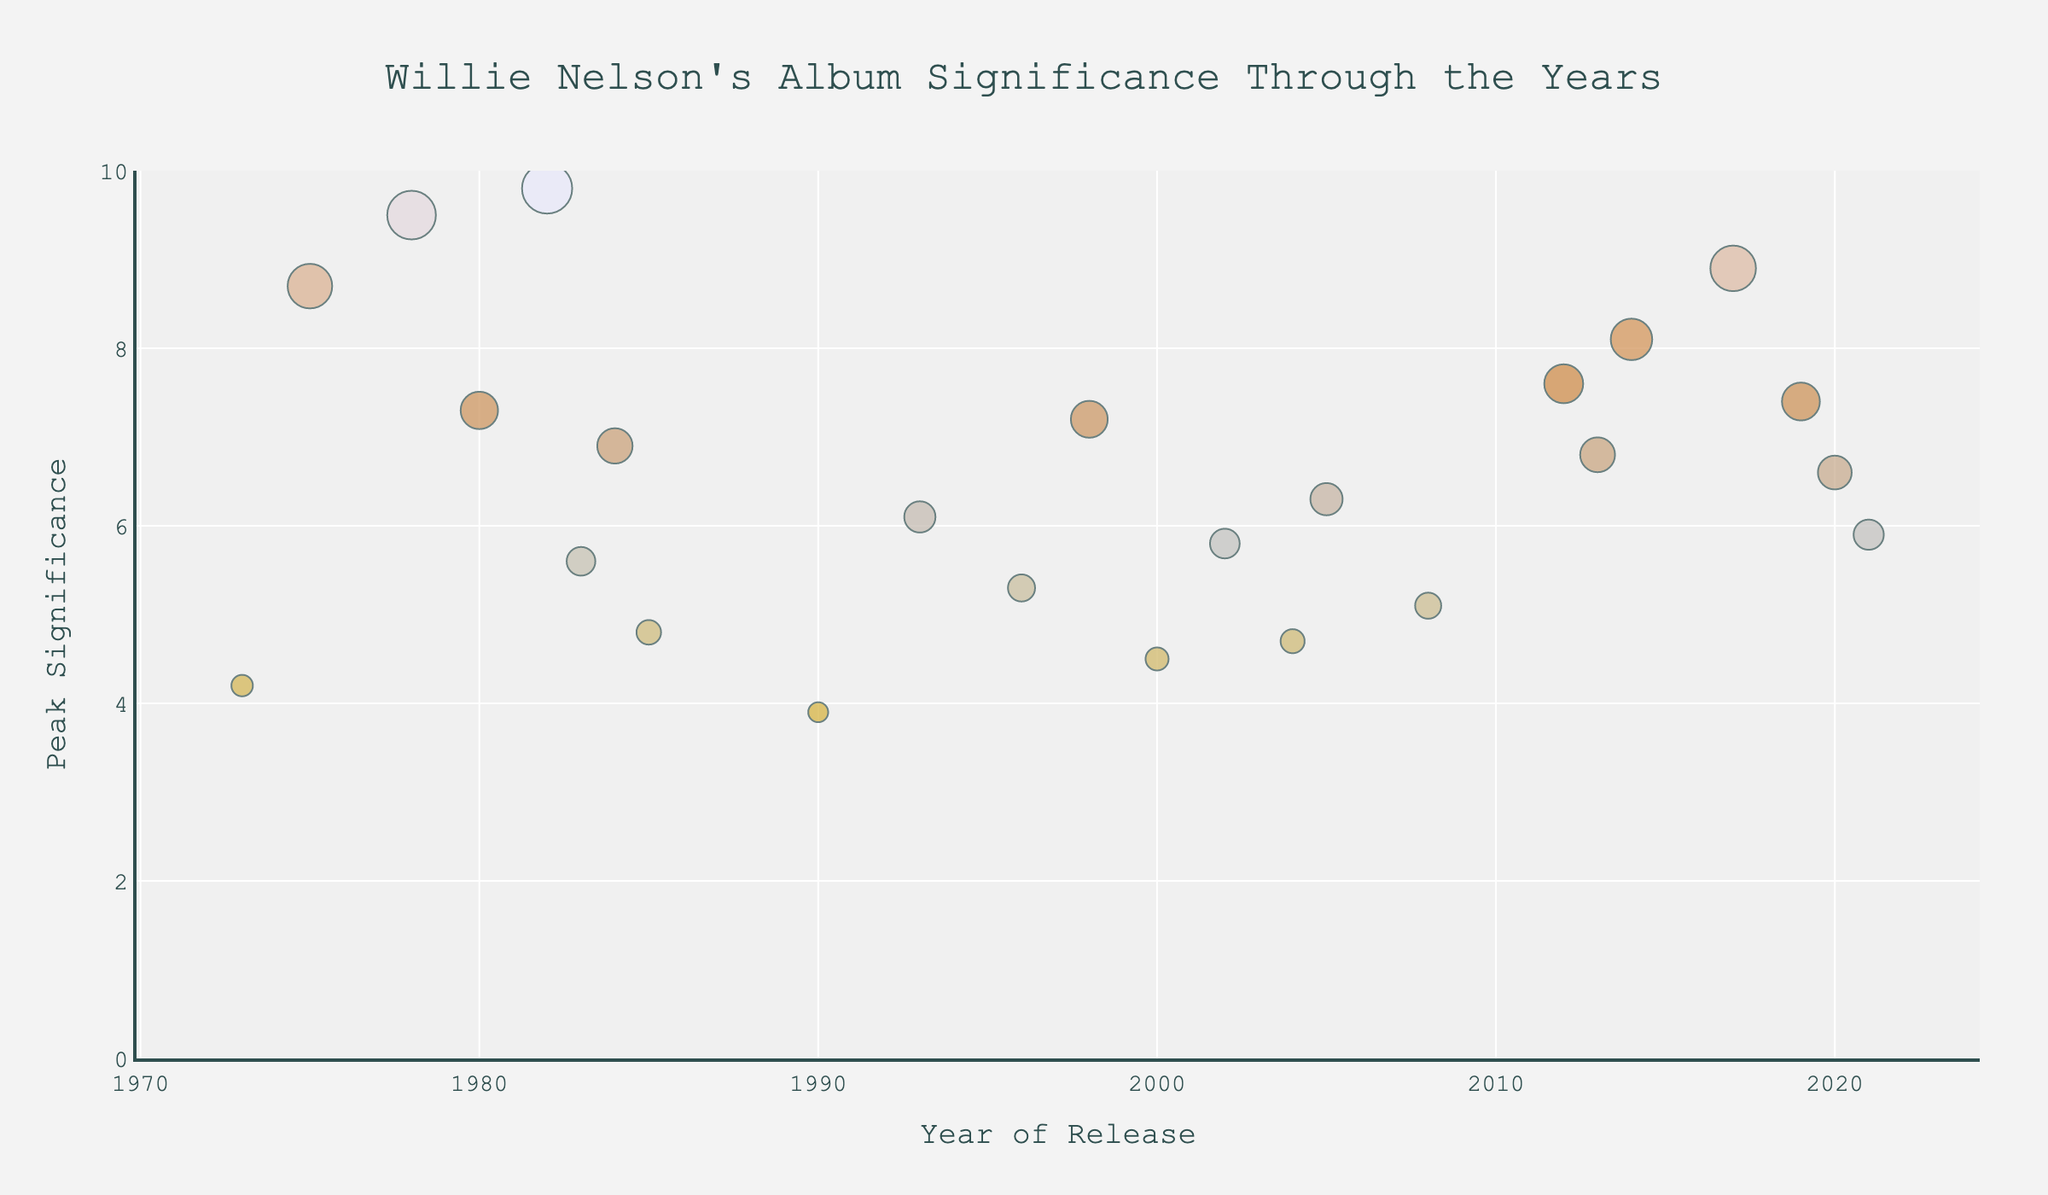How many albums were released by Willie Nelson in the 1970s? Check the data points plotted in the 1970s and count the distinct albums from 1973 to 1978. There are three albums: "Shotgun Willie" (1973), "Red Headed Stranger" (1975), and "Stardust" (1978).
Answer: 3 Which album has the highest peak significance and in what year was it released? Identify the data point with the maximum value on the Peak Significance axis. The highest value is 9.8, corresponding to "Always on My Mind" released in 1982.
Answer: "Always on My Mind," 1982 What is the median peak significance of Willie Nelson's albums released in the 2000s? List the peak significances from the 2000s: 4.5 (2000), 5.8 (2002), 4.7 (2004), 6.3 (2005), and 5.1 (2008). Arrange them and find the middle value: 4.5, 4.7, 5.1, 5.8, 6.3. The median is 5.1.
Answer: 5.1 Which decade shows the largest range in peak significance for Willie Nelson albums? Compare the ranges (max - min) of peak significances for each decade: 1970s (9.5 - 4.2 = 5.3), 1980s (7.3 - 4.8 = 2.5), 1990s (7.2 - 3.9 = 3.3), 2000s (6.3 - 4.5 = 1.8), 2010s (8.9 - 5.9 = 3). The 1970s has the largest range of 5.3.
Answer: 1970s How many albums have a peak significance greater than 7? Identify data points with Peak Significance above 7 and count them: "Red Headed Stranger" (8.7), "Stardust" (9.5), "Always on My Mind" (9.8), "Honeysuckle Rose" (7.3), "Heroes" (7.6), "Band of Brothers" (8.1), "God's Problem Child" (8.9), and "Ride Me Back Home" (7.4). There are eight such albums.
Answer: 8 Between 1980 and 1990, which album has the lowest peak significance, and what is that value? Examine the data points between 1980 and 1990 and identify the lowest value: "Born for Trouble" (1990) with a Peak Significance of 3.9.
Answer: "Born for Trouble," 3.9 What is the average peak significance for albums released in the 2010s? Calculate the mean value for peak significances in the 2010s: 7.6 (2012), 6.8 (2013), 8.1 (2014), 8.9 (2017), 7.4 (2019), 6.6 (2020), 5.9 (2021). Sum up values (7.6 + 6.8 + 8.1 + 8.9 + 7.4 + 6.6 + 5.9 = 51.3) and divide by 7. The average is 51.3/7 = 7.33.
Answer: 7.33 